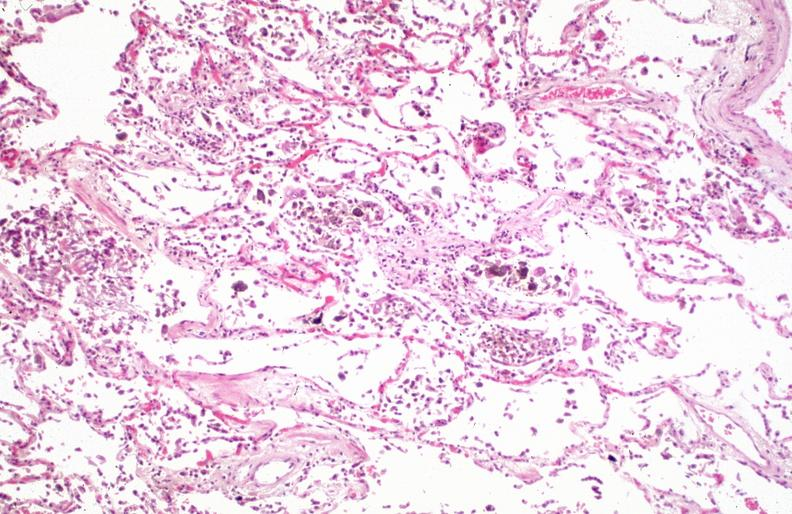where is this?
Answer the question using a single word or phrase. Lung 